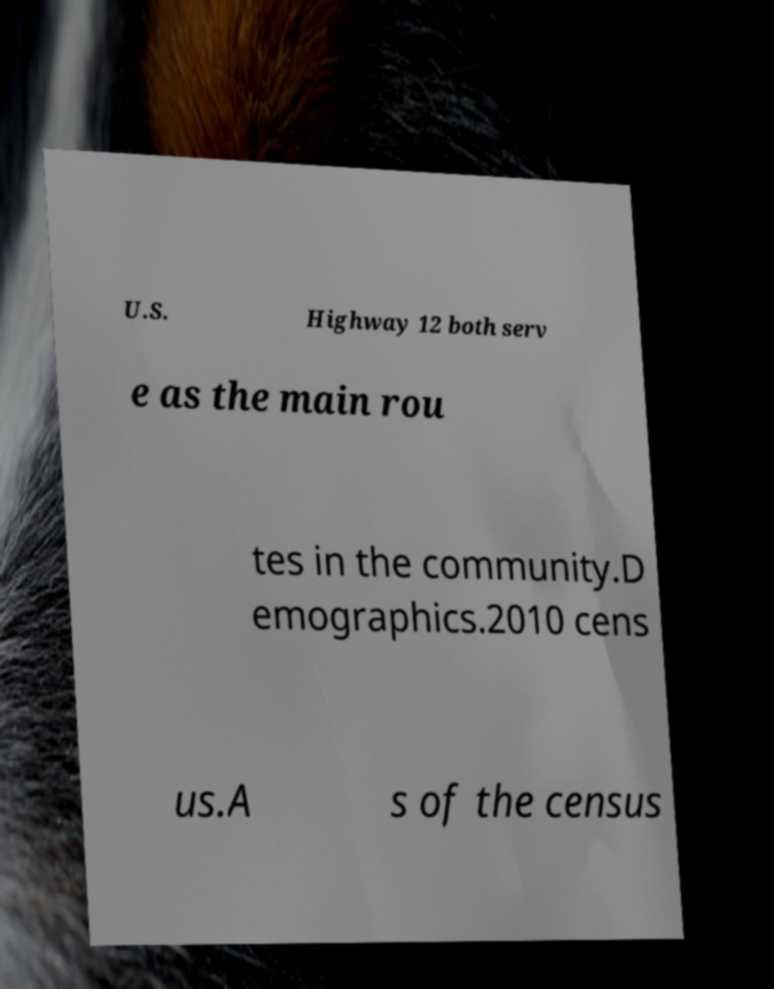Please read and relay the text visible in this image. What does it say? U.S. Highway 12 both serv e as the main rou tes in the community.D emographics.2010 cens us.A s of the census 